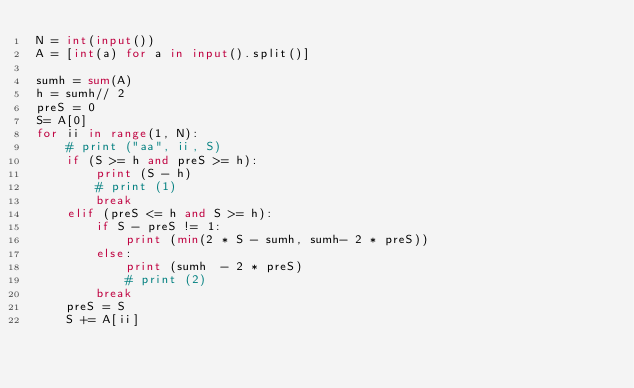Convert code to text. <code><loc_0><loc_0><loc_500><loc_500><_Python_>N = int(input())
A = [int(a) for a in input().split()]

sumh = sum(A)
h = sumh// 2
preS = 0
S= A[0]
for ii in range(1, N):
    # print ("aa", ii, S)
    if (S >= h and preS >= h):
        print (S - h)
        # print (1)
        break
    elif (preS <= h and S >= h):
        if S - preS != 1:
            print (min(2 * S - sumh, sumh- 2 * preS))
        else:
            print (sumh  - 2 * preS)
            # print (2)
        break
    preS = S
    S += A[ii]
</code> 